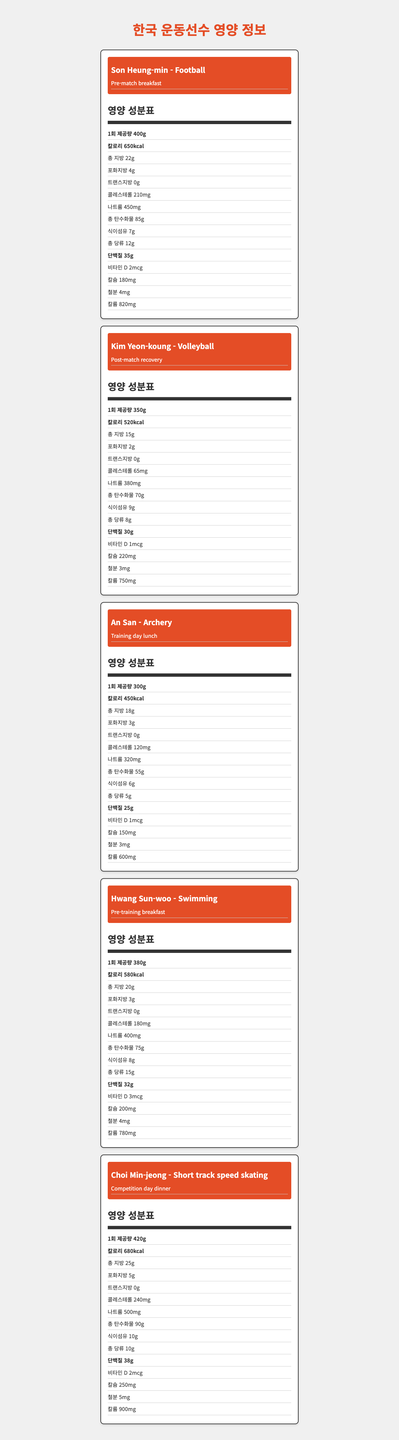what is the serving size for Son Heung-min's pre-match breakfast? The document states that the serving size for Son Heung-min's pre-match breakfast is 400g.
Answer: 400g What is the sodium content in Kim Yeon-koung's post-match recovery meal? The document specifies that the sodium content in Kim Yeon-koung's post-match recovery meal is 380mg.
Answer: 380mg How many grams of protein are in An San's training day lunch? The document lists 25g of protein in An San's training day lunch meal.
Answer: 25g Which athlete's meal has the highest cholesterol content? The document indicates that Choi Min-jeong's competition day dinner has 240mg of cholesterol, the highest among the listed meals.
Answer: Choi Min-jeong What is the total carbohydrate content in Hwang Sun-woo's pre-training breakfast? According to the document, Hwang Sun-woo's pre-training breakfast contains 75g of total carbohydrates.
Answer: 75g Which athlete's meal contains the least amount of fiber? A. Son Heung-min B. Kim Yeon-koung C. An San D. Hwang Sun-woo E. Choi Min-jeong The document shows that An San's training day lunch contains 6g of dietary fiber, which is the least amount amongst the listed options.
Answer: C. An San Whose meal contains the highest amount of potassium? A. Son Heung-min B. Kim Yeon-koung C. An San D. Hwang Sun-woo E. Choi Min-jeong Choi Min-jeong's competition day dinner contains 900mg of potassium, the highest amount among the options provided.
Answer: E. Choi Min-jeong Is there any athlete meal that contains trans fat? The document shows that all the listed meals have 0g trans fat, so there are no athlete meals with trans fat.
Answer: No What is the main idea of this document? The main theme of the document is to offer nutritional breakdowns specific to the athletes' meal plans, making it insightful for understanding their dietary needs and choices.
Answer: The document provides detailed nutritional information for meal plans of various popular South Korean athletes, including data on serving size, calories, fats, cholesterol, sodium, carbohydrates, protein, vitamins, and minerals. What is the most common meal type among the athletes listed? The document mentions the meal types for various athletes, including 'Pre-match breakfast' for Son Heung-min and 'Pre-training breakfast' for Hwang Sun-woo.
Answer: Pre-match breakfast / Pre-training breakfast Can you determine the exact ingredients of An San's training day lunch from this document? The document provides only the nutritional information of each meal, not the specific ingredients used to prepare them.
Answer: Not enough information 